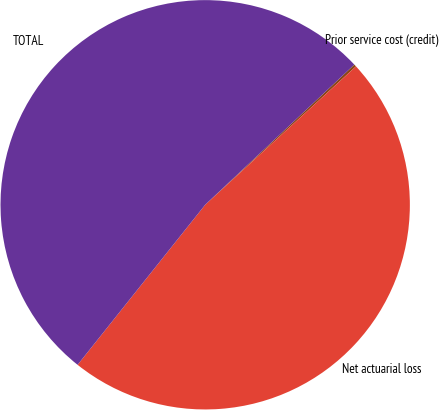<chart> <loc_0><loc_0><loc_500><loc_500><pie_chart><fcel>Prior service cost (credit)<fcel>Net actuarial loss<fcel>TOTAL<nl><fcel>0.19%<fcel>47.53%<fcel>52.28%<nl></chart> 